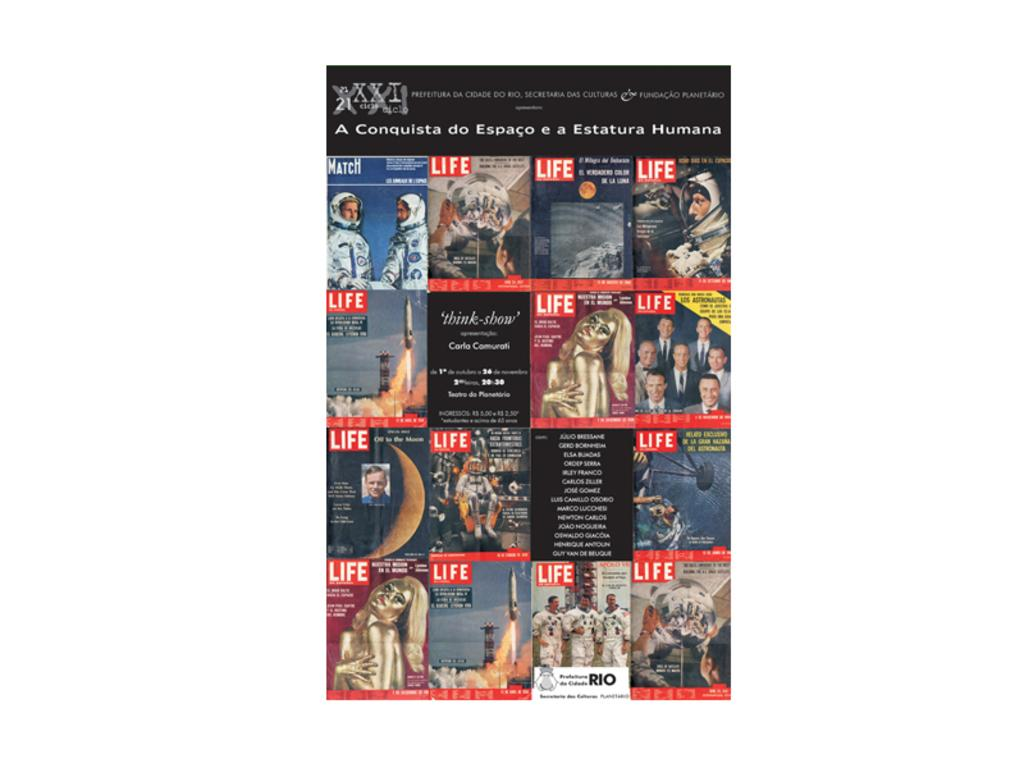<image>
Share a concise interpretation of the image provided. A collage of many different Life magazine covers. 